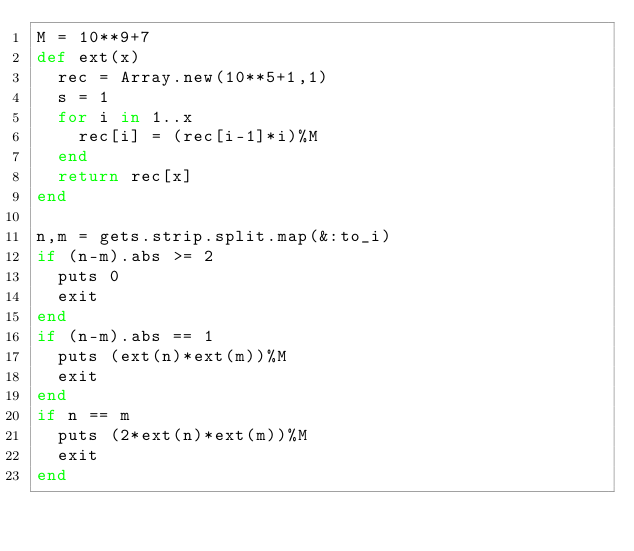<code> <loc_0><loc_0><loc_500><loc_500><_Ruby_>M = 10**9+7
def ext(x)
  rec = Array.new(10**5+1,1)
  s = 1
  for i in 1..x
    rec[i] = (rec[i-1]*i)%M
  end
  return rec[x]
end

n,m = gets.strip.split.map(&:to_i)
if (n-m).abs >= 2
  puts 0
  exit
end
if (n-m).abs == 1
  puts (ext(n)*ext(m))%M
  exit
end
if n == m
  puts (2*ext(n)*ext(m))%M
  exit
end</code> 